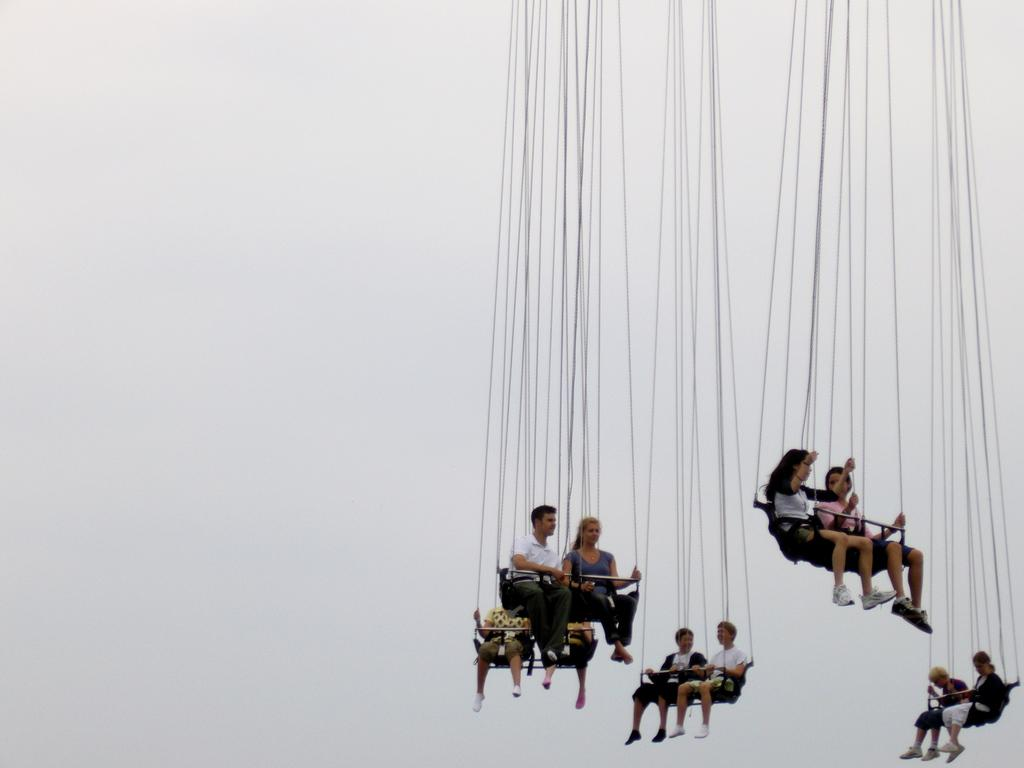What are the people in the image doing? The people in the image are sitting on benches. How are the benches suspended in the image? The benches are attached to wires. What can be seen in the background of the image? The sky is visible in the background of the image. What type of apples are being offered to the people sitting on the benches in the image? There are no apples present in the image. How does the image capture the attention of the viewers? The image itself does not have the ability to capture the attention of viewers; it is a static representation of the scene. 